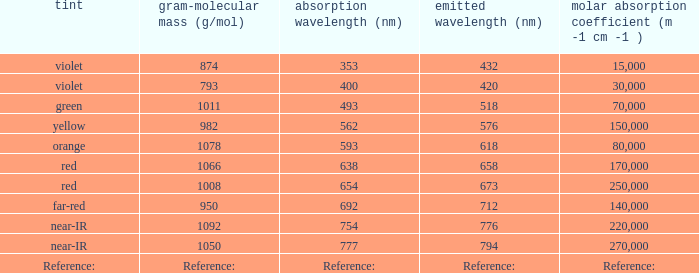What is the Absorbtion (in nanometers) of the color Violet with an emission of 432 nm? 353.0. 